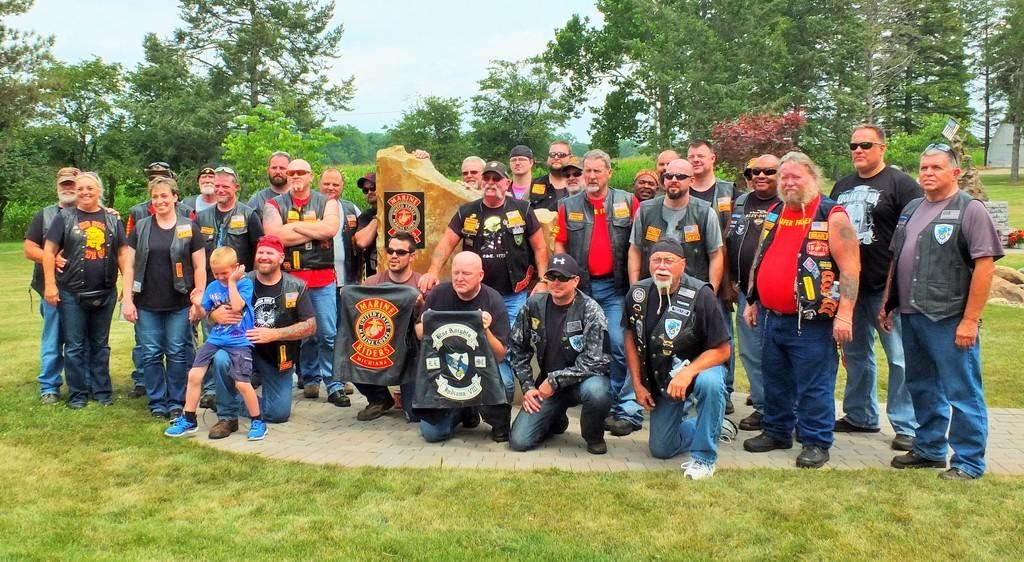What are the people in the image doing? Some persons are standing, and some are crouching in the image. What can be seen in the background of the image? There are trees and the clear sky visible in the background of the image. How many dimes can be seen on the ground in the image? There are no dimes visible on the ground in the image. What type of rat can be seen interacting with the persons in the image? There are no rats present in the image; only persons and trees are visible. 